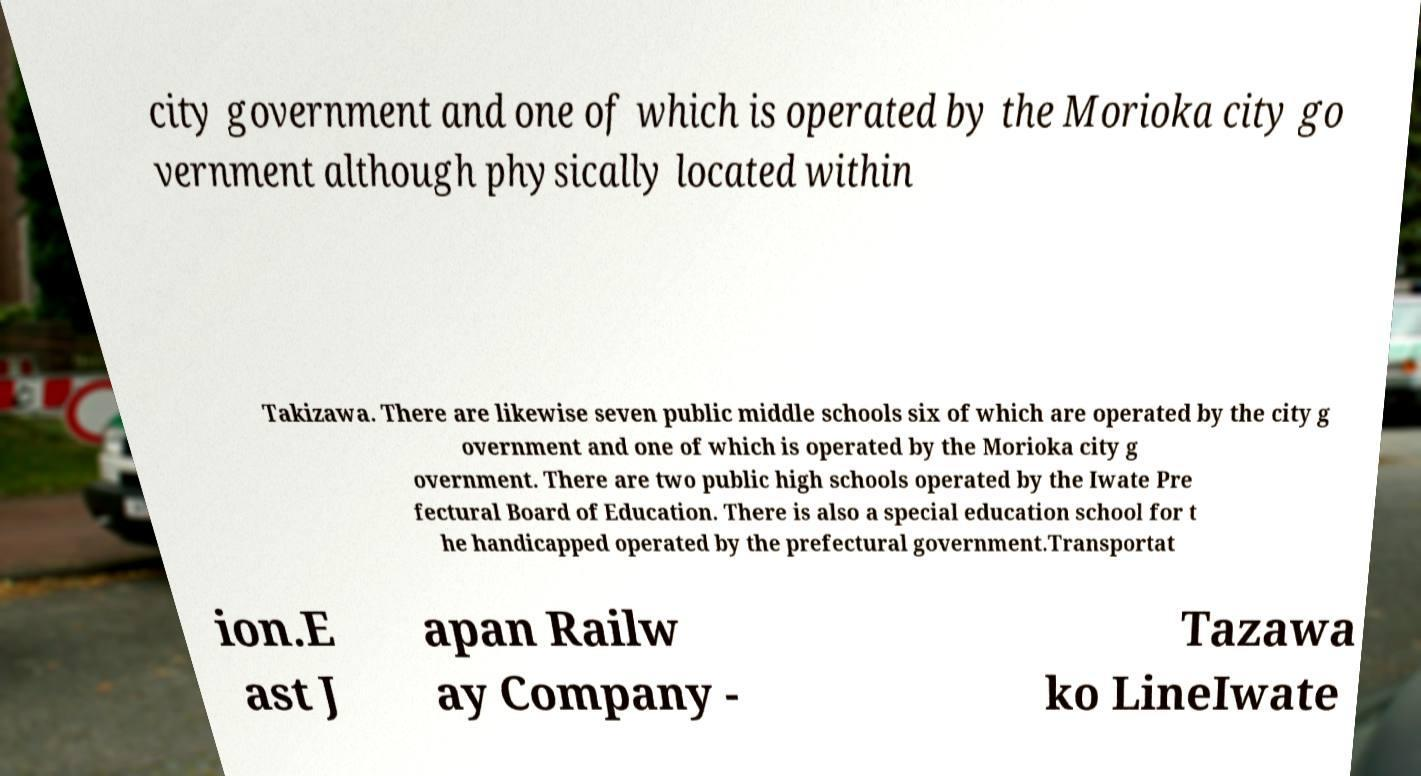I need the written content from this picture converted into text. Can you do that? city government and one of which is operated by the Morioka city go vernment although physically located within Takizawa. There are likewise seven public middle schools six of which are operated by the city g overnment and one of which is operated by the Morioka city g overnment. There are two public high schools operated by the Iwate Pre fectural Board of Education. There is also a special education school for t he handicapped operated by the prefectural government.Transportat ion.E ast J apan Railw ay Company - Tazawa ko LineIwate 